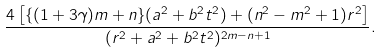Convert formula to latex. <formula><loc_0><loc_0><loc_500><loc_500>\frac { 4 \left [ \{ ( 1 + 3 \gamma ) m + n \} ( a ^ { 2 } + b ^ { 2 } t ^ { 2 } ) + ( n ^ { 2 } - m ^ { 2 } + 1 ) r ^ { 2 } \right ] } { ( r ^ { 2 } + a ^ { 2 } + b ^ { 2 } t ^ { 2 } ) ^ { 2 m - n + 1 } } .</formula> 